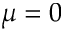<formula> <loc_0><loc_0><loc_500><loc_500>\mu = 0</formula> 